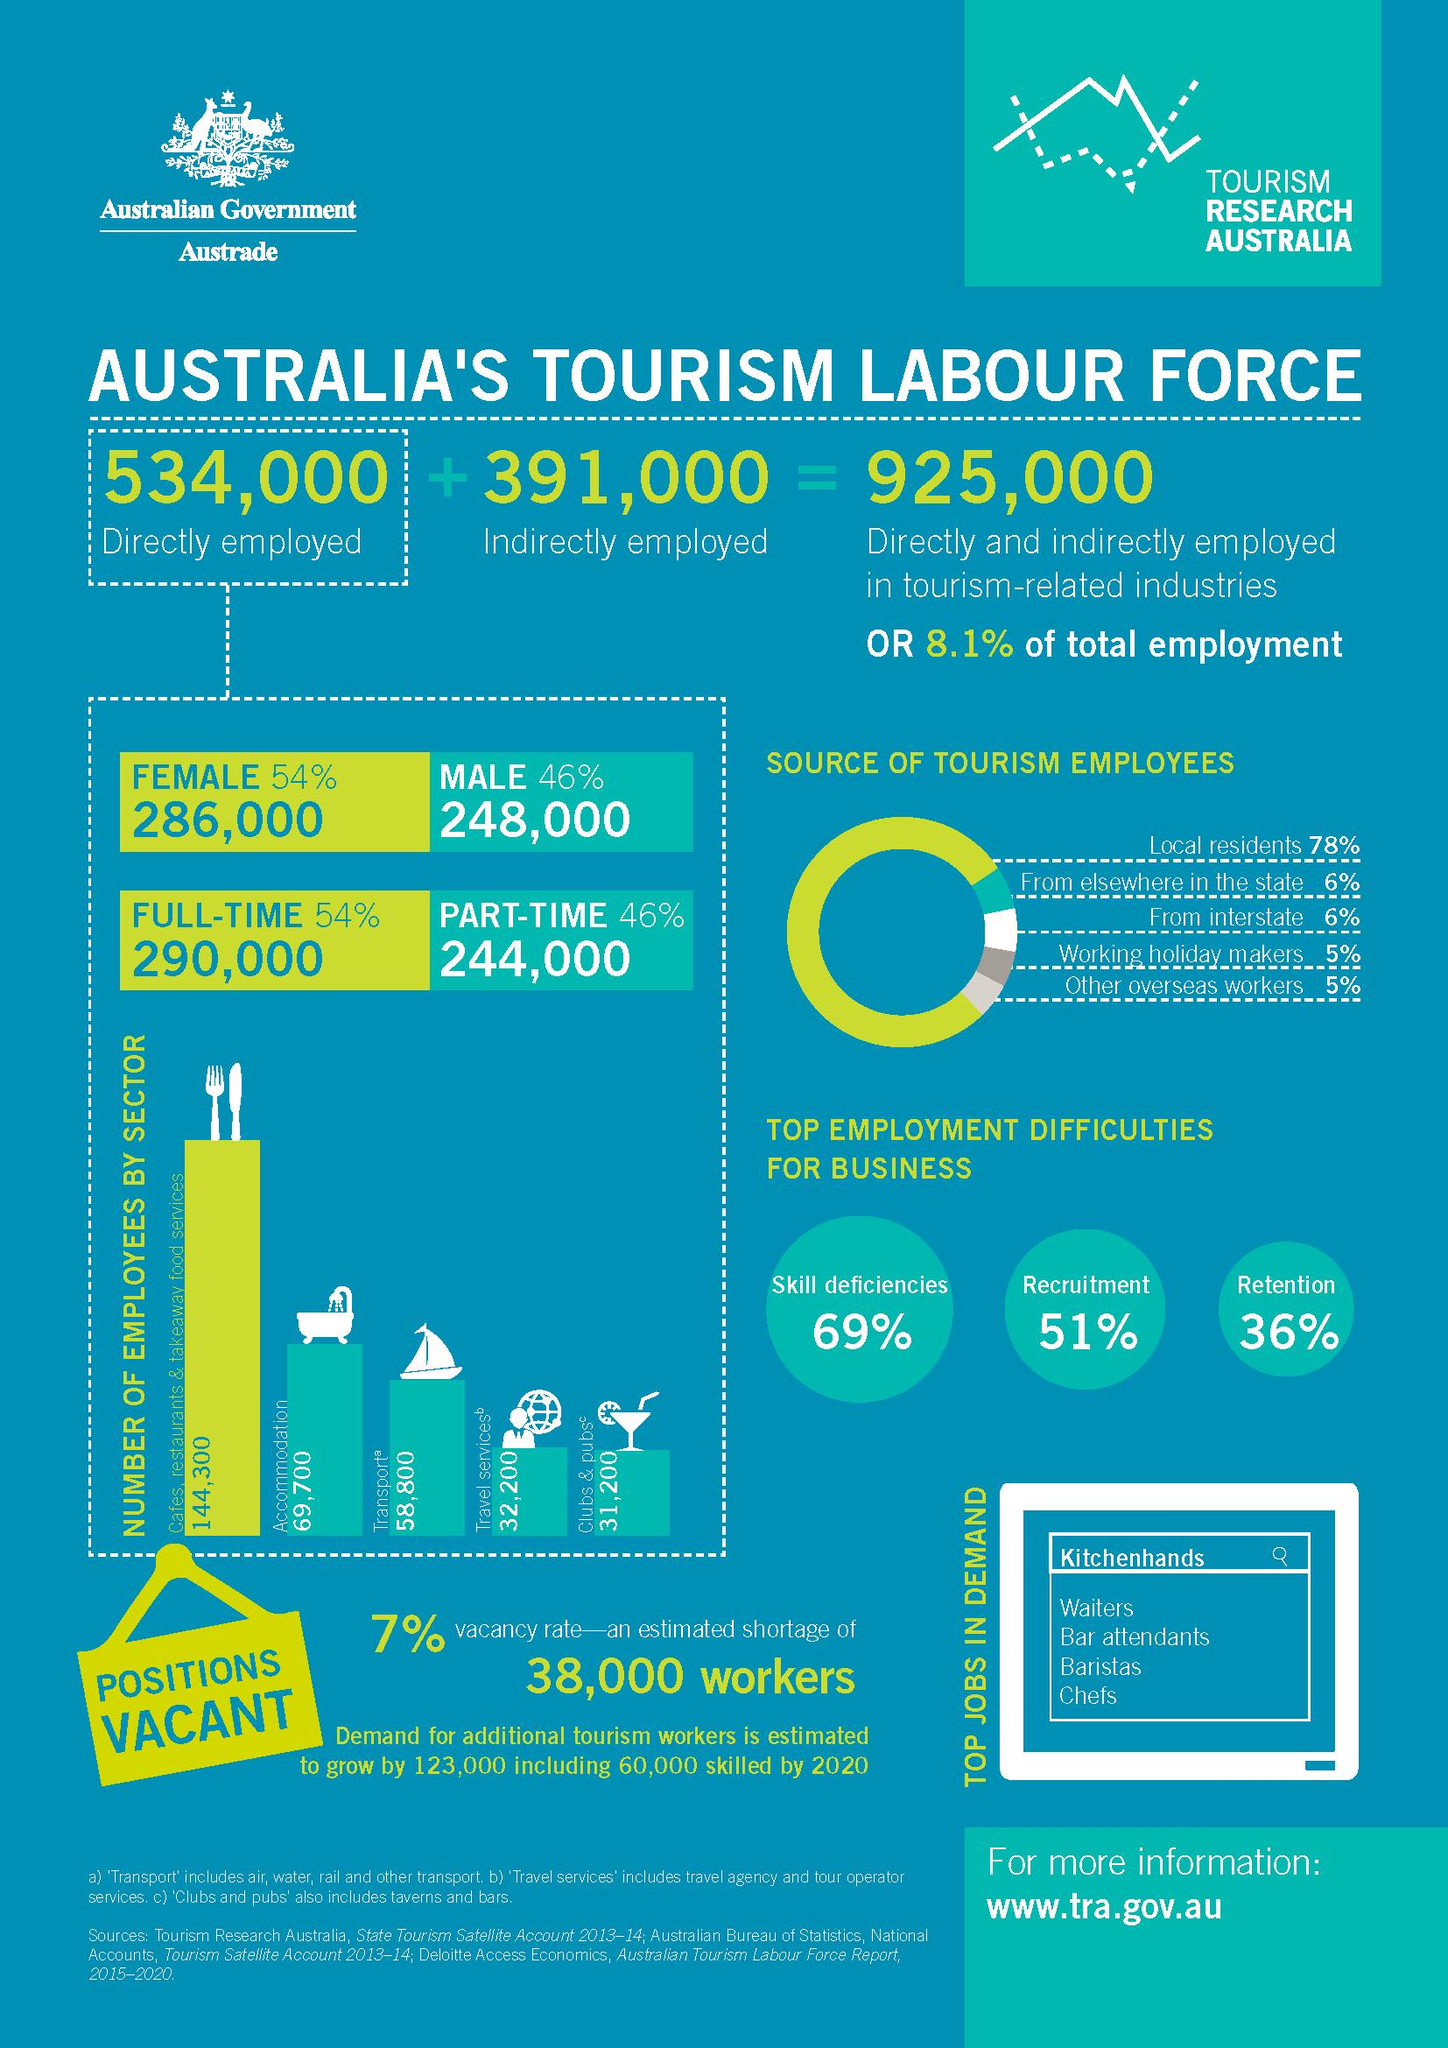Point out several critical features in this image. The count of full-time employees is approximately 290,000. The indirectly employed in the tourism industry are significantly fewer than the directly employed, with a difference of 143,000. There are approximately 91,000 employees in the transport and travel services industry. The female employee is more than 8% higher than the male employee. The number of employees from working holiday makers is equal to the number of employees from other overseas workers. 